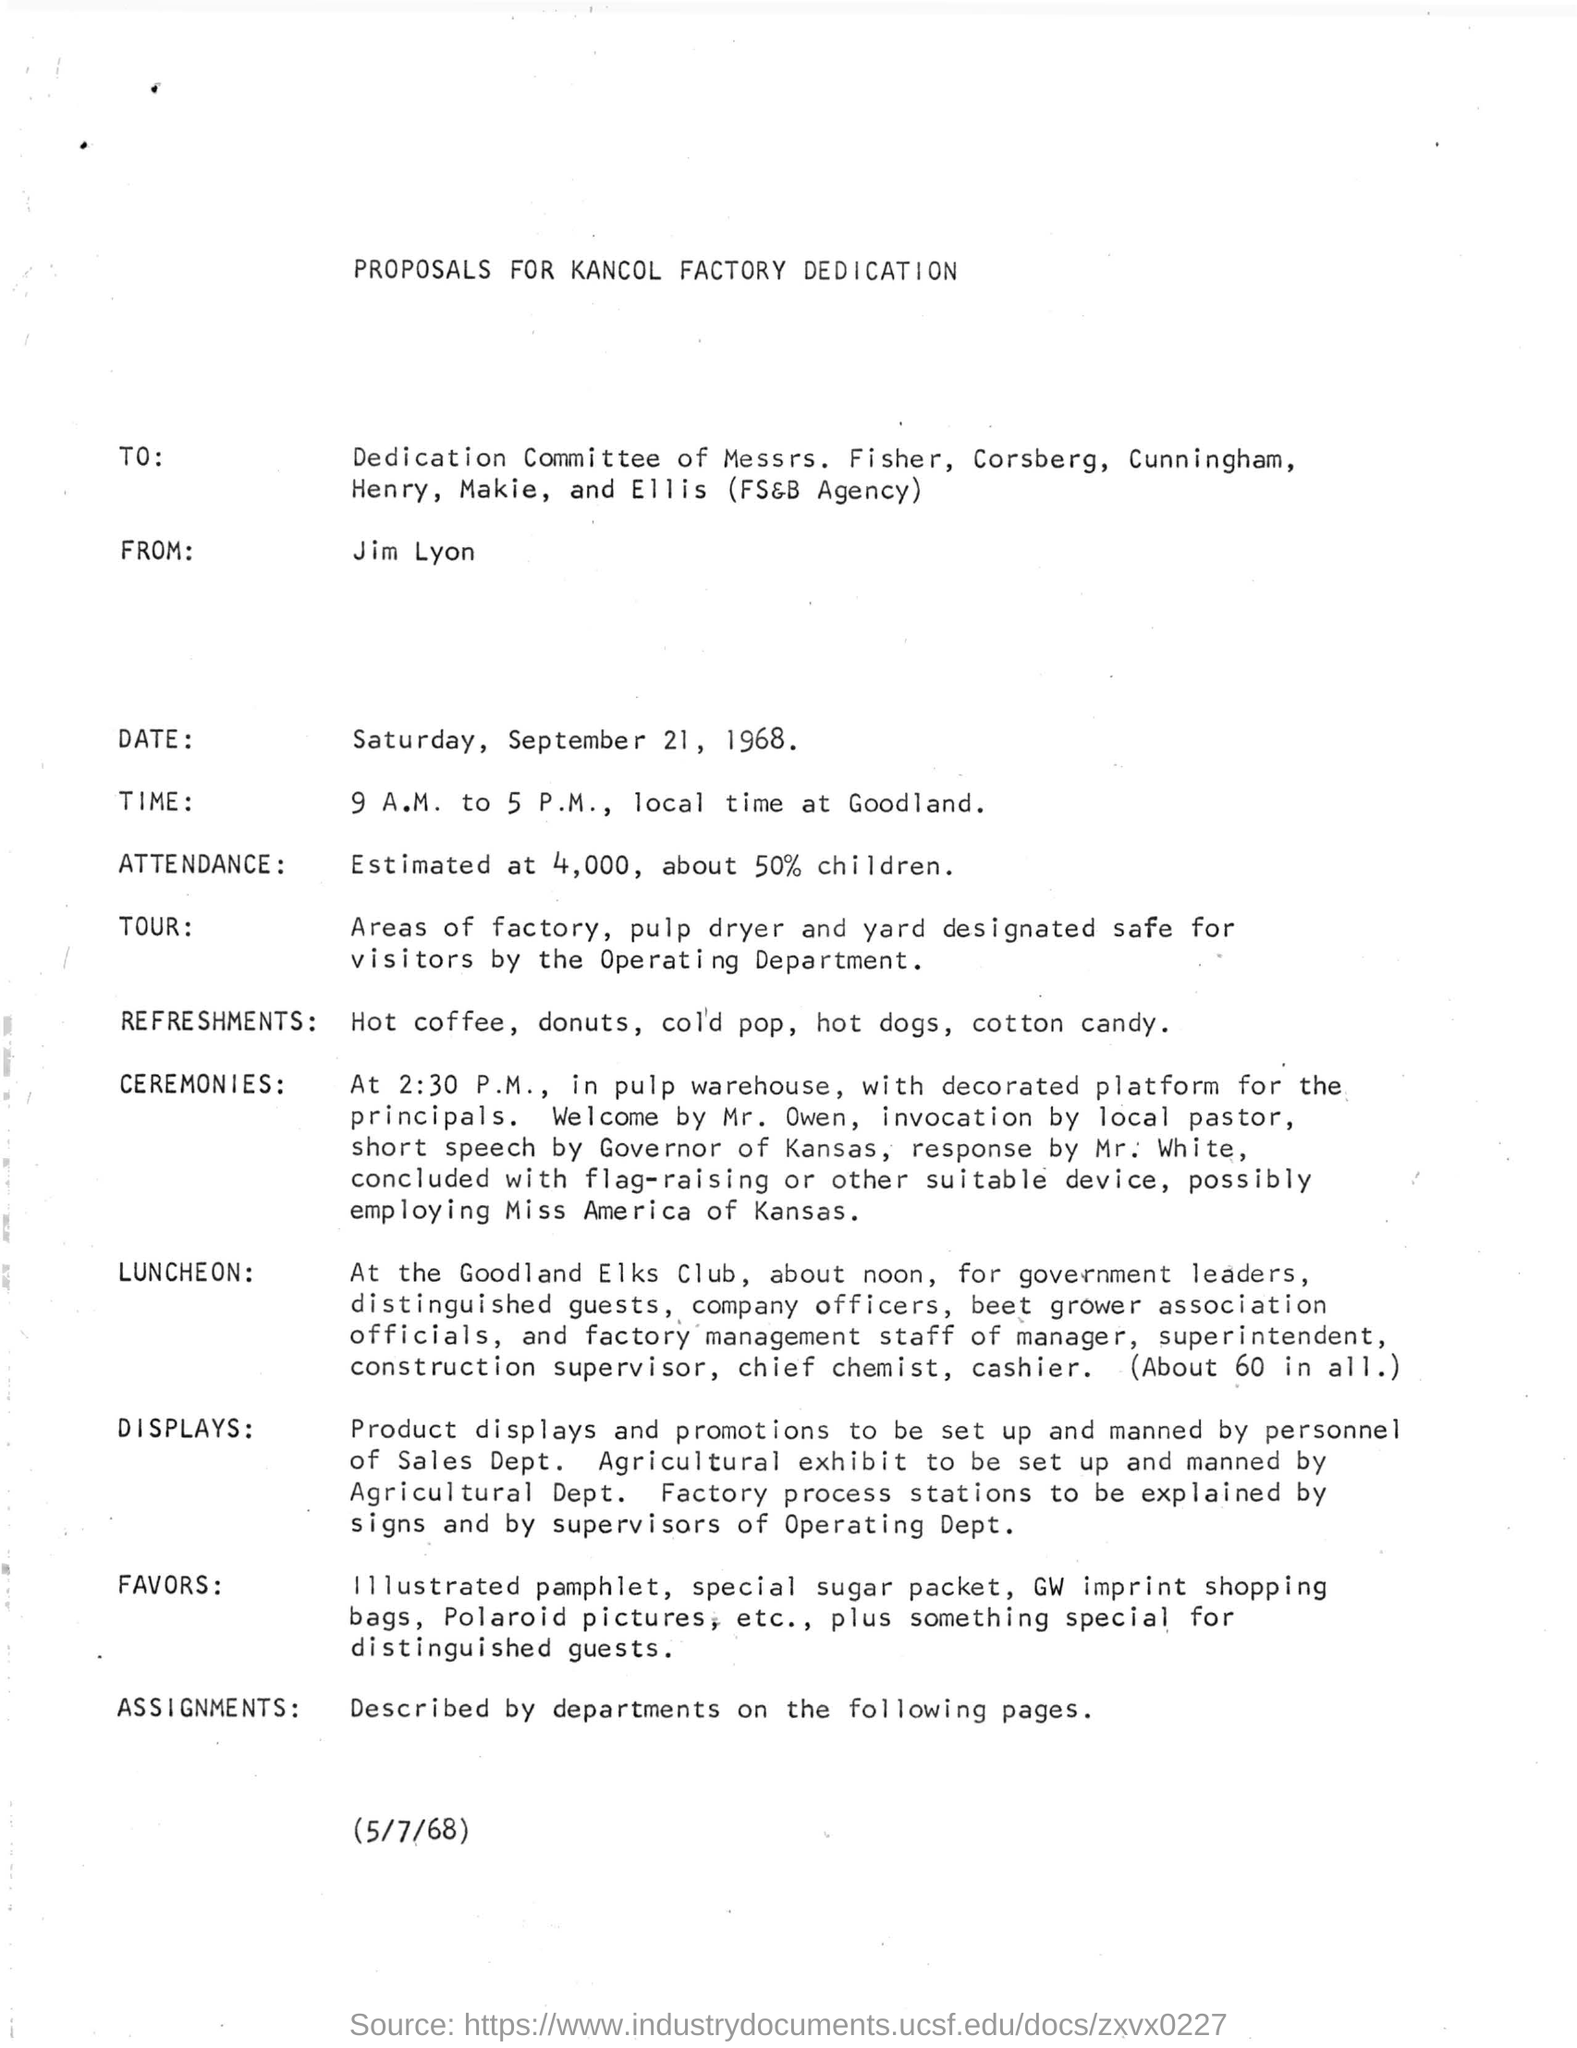Who is the sender of the proposal?
Give a very brief answer. JIM LYON. Who welcomes the ceremony?
Ensure brevity in your answer.  Mr. Owen. Where is the LUNCHEON arranged?
Provide a short and direct response. Goodland Elks Club. 